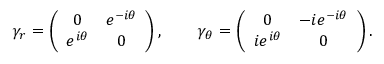<formula> <loc_0><loc_0><loc_500><loc_500>\gamma _ { r } = \left ( \begin{array} { c c } { 0 } & { { e ^ { - i \theta } } } \\ { { e ^ { i \theta } } } & { 0 } \end{array} \right ) , \quad \gamma _ { \theta } = \left ( \begin{array} { c c } { 0 } & { { - i e ^ { - i \theta } } } \\ { { i e ^ { i \theta } } } & { 0 } \end{array} \right ) .</formula> 